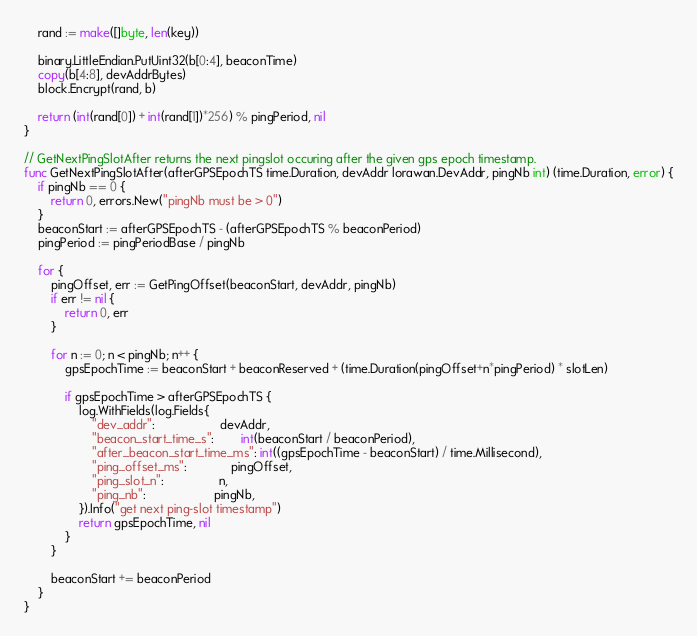Convert code to text. <code><loc_0><loc_0><loc_500><loc_500><_Go_>	rand := make([]byte, len(key))

	binary.LittleEndian.PutUint32(b[0:4], beaconTime)
	copy(b[4:8], devAddrBytes)
	block.Encrypt(rand, b)

	return (int(rand[0]) + int(rand[1])*256) % pingPeriod, nil
}

// GetNextPingSlotAfter returns the next pingslot occuring after the given gps epoch timestamp.
func GetNextPingSlotAfter(afterGPSEpochTS time.Duration, devAddr lorawan.DevAddr, pingNb int) (time.Duration, error) {
	if pingNb == 0 {
		return 0, errors.New("pingNb must be > 0")
	}
	beaconStart := afterGPSEpochTS - (afterGPSEpochTS % beaconPeriod)
	pingPeriod := pingPeriodBase / pingNb

	for {
		pingOffset, err := GetPingOffset(beaconStart, devAddr, pingNb)
		if err != nil {
			return 0, err
		}

		for n := 0; n < pingNb; n++ {
			gpsEpochTime := beaconStart + beaconReserved + (time.Duration(pingOffset+n*pingPeriod) * slotLen)

			if gpsEpochTime > afterGPSEpochTS {
				log.WithFields(log.Fields{
					"dev_addr":                   devAddr,
					"beacon_start_time_s":        int(beaconStart / beaconPeriod),
					"after_beacon_start_time_ms": int((gpsEpochTime - beaconStart) / time.Millisecond),
					"ping_offset_ms":             pingOffset,
					"ping_slot_n":                n,
					"ping_nb":                    pingNb,
				}).Info("get next ping-slot timestamp")
				return gpsEpochTime, nil
			}
		}

		beaconStart += beaconPeriod
	}
}
</code> 